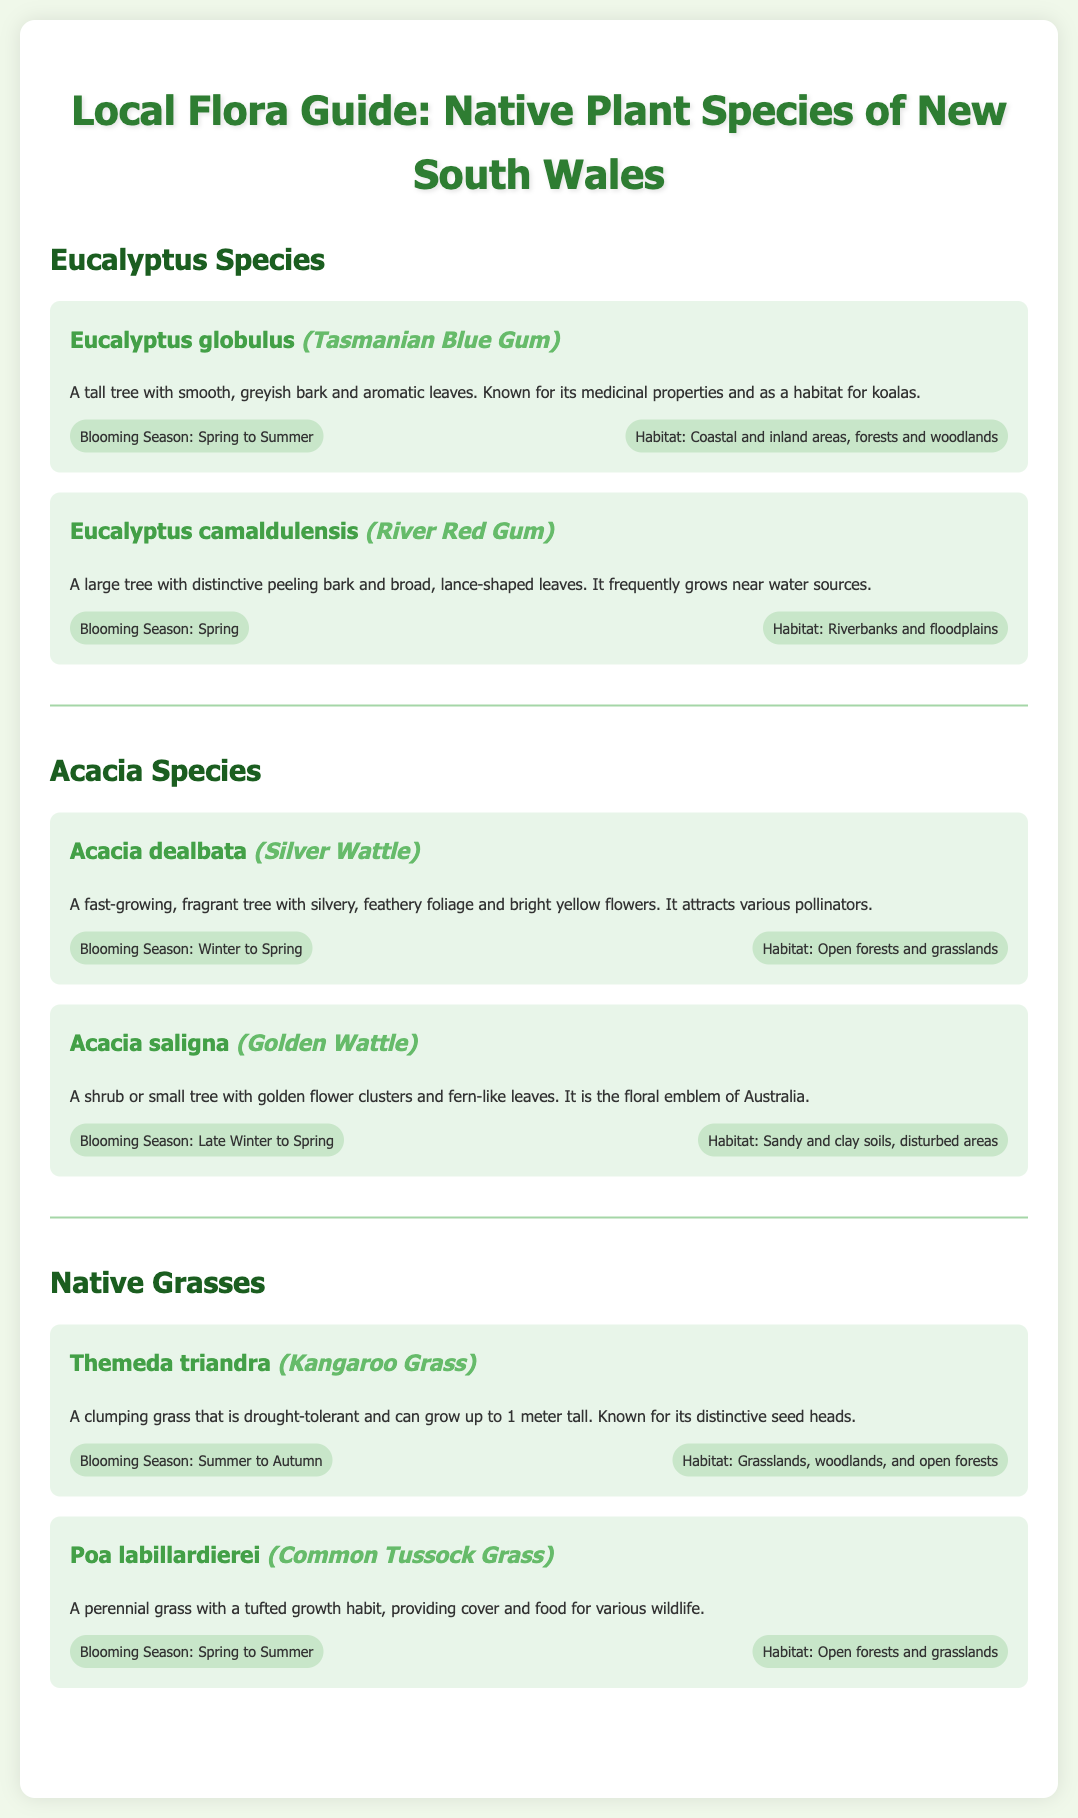What is the common name for Eucalyptus globulus? The common name for Eucalyptus globulus is found in the description section of the plant, specifically marked as (Tasmanian Blue Gum).
Answer: Tasmanian Blue Gum What is the blooming season for Acacia dealbata? The blooming season for Acacia dealbata is provided in its information section, stating that it blooms from Winter to Spring.
Answer: Winter to Spring How tall can Kangaroo Grass grow? The height information for Kangaroo Grass is mentioned in its description, stating it can grow up to 1 meter tall.
Answer: 1 meter Which habitat does the River Red Gum prefer? The habitat preference for River Red Gum is indicated in its details, showing that it frequently grows near riverbanks and floodplains.
Answer: Riverbanks and floodplains What color are the flowers of the Golden Wattle? The flower color of the Golden Wattle is specified in its description, stating that it has golden flower clusters.
Answer: Golden Which species is known for its medicinal properties? The Eucalyptus globulus is noted in the document for its medicinal properties, as stated in its description section.
Answer: Eucalyptus globulus What type of plant is Acacia saligna? The information for Acacia saligna specifies it as a shrub or small tree, which is a crucial detail in understanding its classification.
Answer: Shrub or small tree During which season does Themeda triandra bloom? The seasonal blooming period for Themeda triandra is described as Summer to Autumn in the document.
Answer: Summer to Autumn How is the document organized? The organization of the document is structured into sections based on plant types, such as Eucalyptus Species and Acacia Species, among others.
Answer: Sections by plant types 